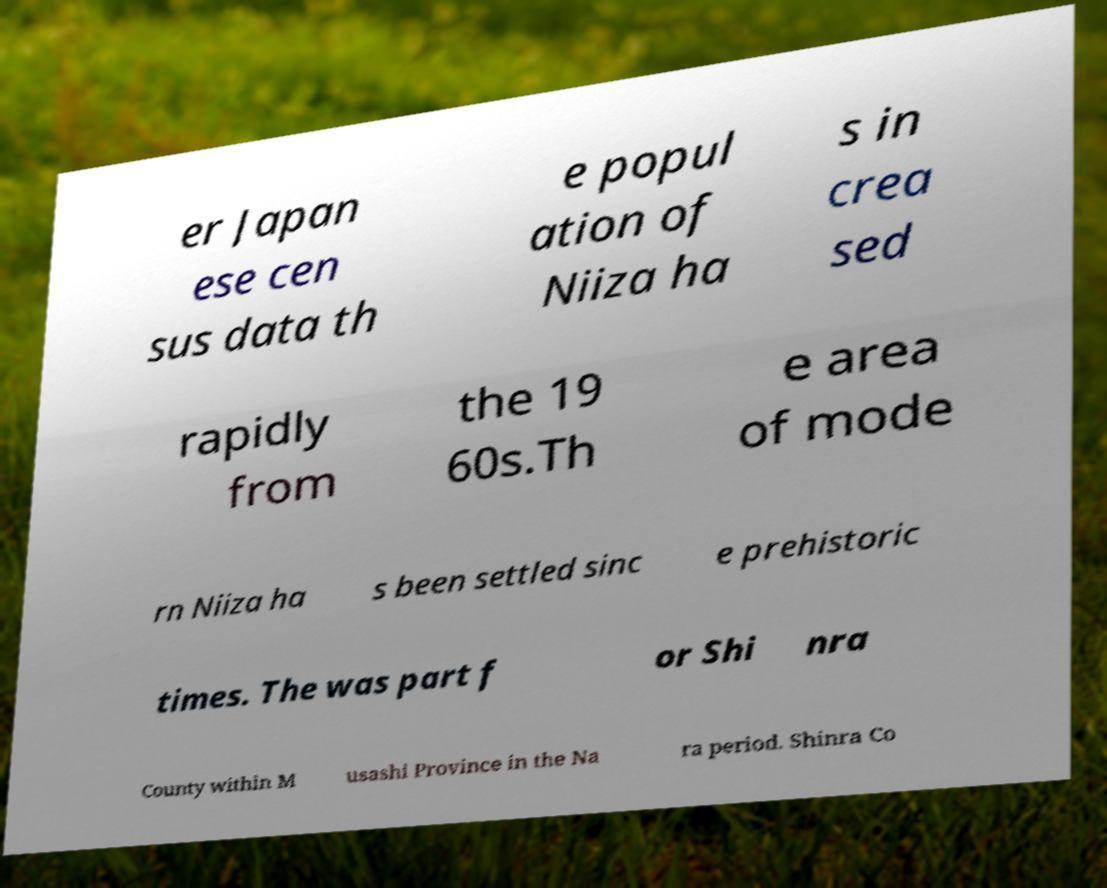Could you assist in decoding the text presented in this image and type it out clearly? er Japan ese cen sus data th e popul ation of Niiza ha s in crea sed rapidly from the 19 60s.Th e area of mode rn Niiza ha s been settled sinc e prehistoric times. The was part f or Shi nra County within M usashi Province in the Na ra period. Shinra Co 